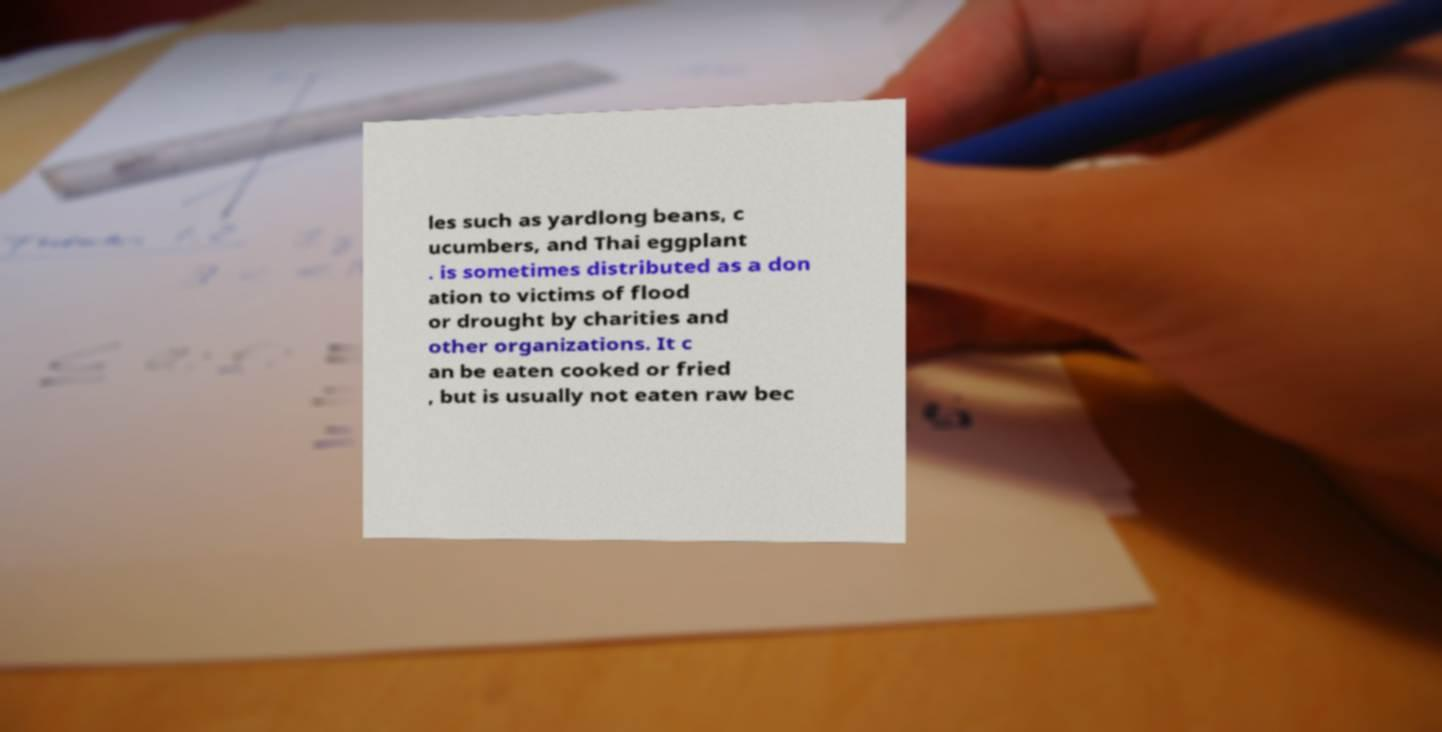I need the written content from this picture converted into text. Can you do that? les such as yardlong beans, c ucumbers, and Thai eggplant . is sometimes distributed as a don ation to victims of flood or drought by charities and other organizations. It c an be eaten cooked or fried , but is usually not eaten raw bec 